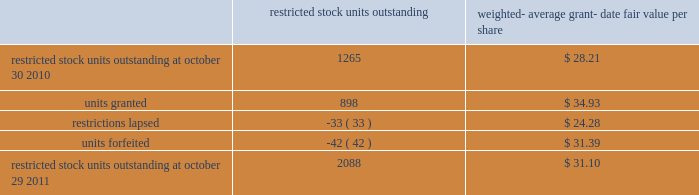The total intrinsic value of options exercised ( i.e .
The difference between the market price at exercise and the price paid by the employee to exercise the options ) during fiscal 2011 , 2010 and 2009 was $ 96.5 million , $ 29.6 million and $ 4.7 million , respectively .
The total amount of proceeds received by the company from exercise of these options during fiscal 2011 , 2010 and 2009 was $ 217.4 million , $ 240.4 million and $ 15.1 million , respectively .
Proceeds from stock option exercises pursuant to employee stock plans in the company 2019s statement of cash flows of $ 217.2 million , $ 216.1 million and $ 12.4 million for fiscal 2011 , 2010 and 2009 , respectively , are net of the value of shares surrendered by employees in certain limited circumstances to satisfy the exercise price of options , and to satisfy employee tax obligations upon vesting of restricted stock or restricted stock units and in connection with the exercise of stock options granted to the company 2019s employees under the company 2019s equity compensation plans .
The withholding amount is based on the company 2019s minimum statutory withholding requirement .
A summary of the company 2019s restricted stock unit award activity as of october 29 , 2011 and changes during the year then ended is presented below : restricted outstanding weighted- average grant- date fair value per share .
As of october 29 , 2011 , there was $ 88.6 million of total unrecognized compensation cost related to unvested share-based awards comprised of stock options and restricted stock units .
That cost is expected to be recognized over a weighted-average period of 1.3 years .
The total grant-date fair value of shares that vested during fiscal 2011 , 2010 and 2009 was approximately $ 49.6 million , $ 67.7 million and $ 74.4 million , respectively .
Common stock repurchase program the company 2019s common stock repurchase program has been in place since august 2004 .
In the aggregate , the board of directors has authorized the company to repurchase $ 5 billion of the company 2019s common stock under the program .
Under the program , the company may repurchase outstanding shares of its common stock from time to time in the open market and through privately negotiated transactions .
Unless terminated earlier by resolution of the company 2019s board of directors , the repurchase program will expire when the company has repurchased all shares authorized under the program .
As of october 29 , 2011 , the company had repurchased a total of approximately 125.0 million shares of its common stock for approximately $ 4278.5 million under this program .
An additional $ 721.5 million remains available for repurchase of shares under the current authorized program .
The repurchased shares are held as authorized but unissued shares of common stock .
Any future common stock repurchases will be dependent upon several factors , including the amount of cash available to the company in the united states and the company 2019s financial performance , outlook and liquidity .
The company also from time to time repurchases shares in settlement of employee tax withholding obligations due upon the vesting of restricted stock units , or in certain limited circumstances to satisfy the exercise price of options granted to the company 2019s employees under the company 2019s equity compensation plans .
Analog devices , inc .
Notes to consolidated financial statements 2014 ( continued ) .
What is the growth rate in total total amount of proceeds received by the company from exercise of options in 2011? 
Computations: ((217.4 - 216.1) / 216.1)
Answer: 0.00602. 